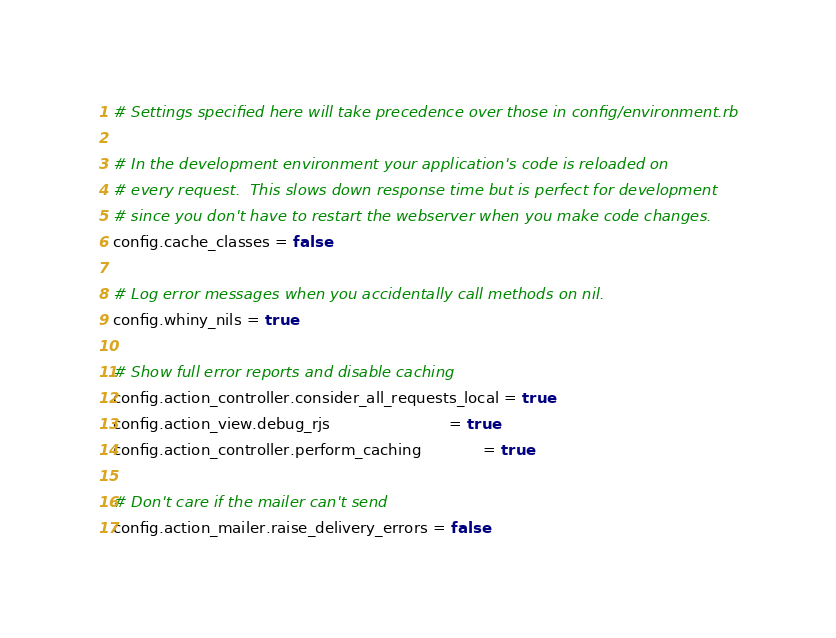Convert code to text. <code><loc_0><loc_0><loc_500><loc_500><_Ruby_># Settings specified here will take precedence over those in config/environment.rb

# In the development environment your application's code is reloaded on
# every request.  This slows down response time but is perfect for development
# since you don't have to restart the webserver when you make code changes.
config.cache_classes = false

# Log error messages when you accidentally call methods on nil.
config.whiny_nils = true

# Show full error reports and disable caching
config.action_controller.consider_all_requests_local = true
config.action_view.debug_rjs                         = true
config.action_controller.perform_caching             = true

# Don't care if the mailer can't send
config.action_mailer.raise_delivery_errors = false
</code> 